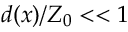<formula> <loc_0><loc_0><loc_500><loc_500>d ( x ) / Z _ { 0 } < < 1</formula> 